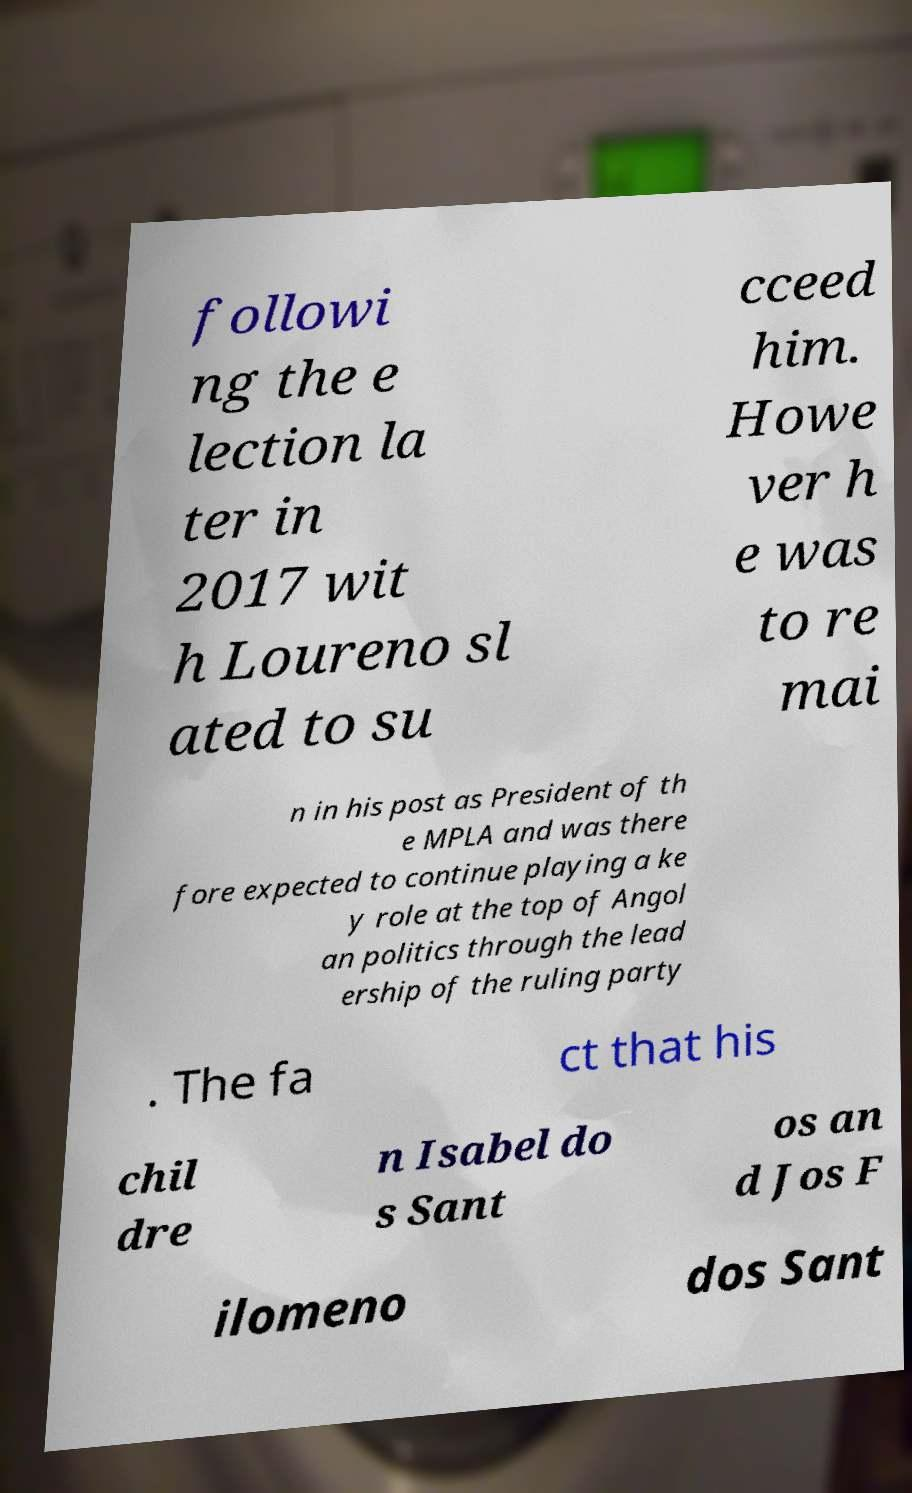Please read and relay the text visible in this image. What does it say? followi ng the e lection la ter in 2017 wit h Loureno sl ated to su cceed him. Howe ver h e was to re mai n in his post as President of th e MPLA and was there fore expected to continue playing a ke y role at the top of Angol an politics through the lead ership of the ruling party . The fa ct that his chil dre n Isabel do s Sant os an d Jos F ilomeno dos Sant 